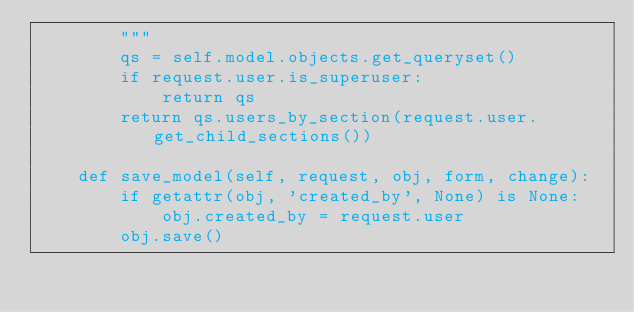<code> <loc_0><loc_0><loc_500><loc_500><_Python_>        """
        qs = self.model.objects.get_queryset()
        if request.user.is_superuser:
            return qs
        return qs.users_by_section(request.user.get_child_sections())

    def save_model(self, request, obj, form, change):
        if getattr(obj, 'created_by', None) is None:
            obj.created_by = request.user
        obj.save()
</code> 